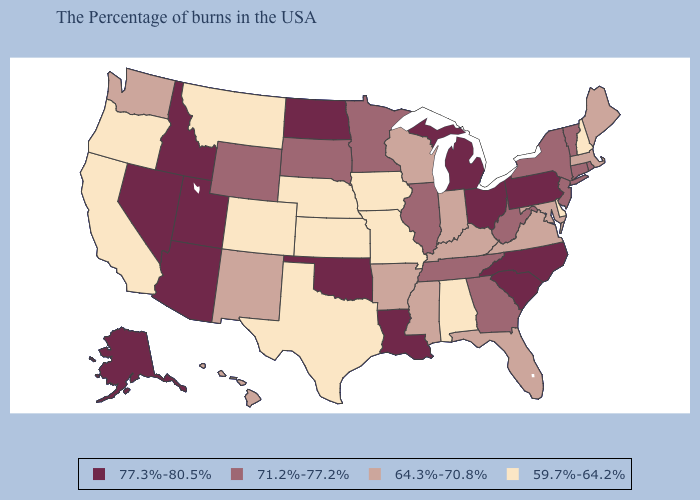Which states have the highest value in the USA?
Give a very brief answer. Pennsylvania, North Carolina, South Carolina, Ohio, Michigan, Louisiana, Oklahoma, North Dakota, Utah, Arizona, Idaho, Nevada, Alaska. Does the first symbol in the legend represent the smallest category?
Short answer required. No. What is the highest value in states that border Arizona?
Write a very short answer. 77.3%-80.5%. What is the value of Massachusetts?
Keep it brief. 64.3%-70.8%. Does Kentucky have the highest value in the USA?
Concise answer only. No. Does Montana have a lower value than Washington?
Be succinct. Yes. Among the states that border Washington , does Oregon have the highest value?
Short answer required. No. What is the highest value in the USA?
Answer briefly. 77.3%-80.5%. Does Georgia have the same value as Virginia?
Quick response, please. No. Name the states that have a value in the range 71.2%-77.2%?
Answer briefly. Rhode Island, Vermont, Connecticut, New York, New Jersey, West Virginia, Georgia, Tennessee, Illinois, Minnesota, South Dakota, Wyoming. What is the value of Nevada?
Quick response, please. 77.3%-80.5%. What is the value of Arizona?
Give a very brief answer. 77.3%-80.5%. Does Louisiana have the highest value in the South?
Answer briefly. Yes. What is the lowest value in the USA?
Give a very brief answer. 59.7%-64.2%. Does the map have missing data?
Give a very brief answer. No. 